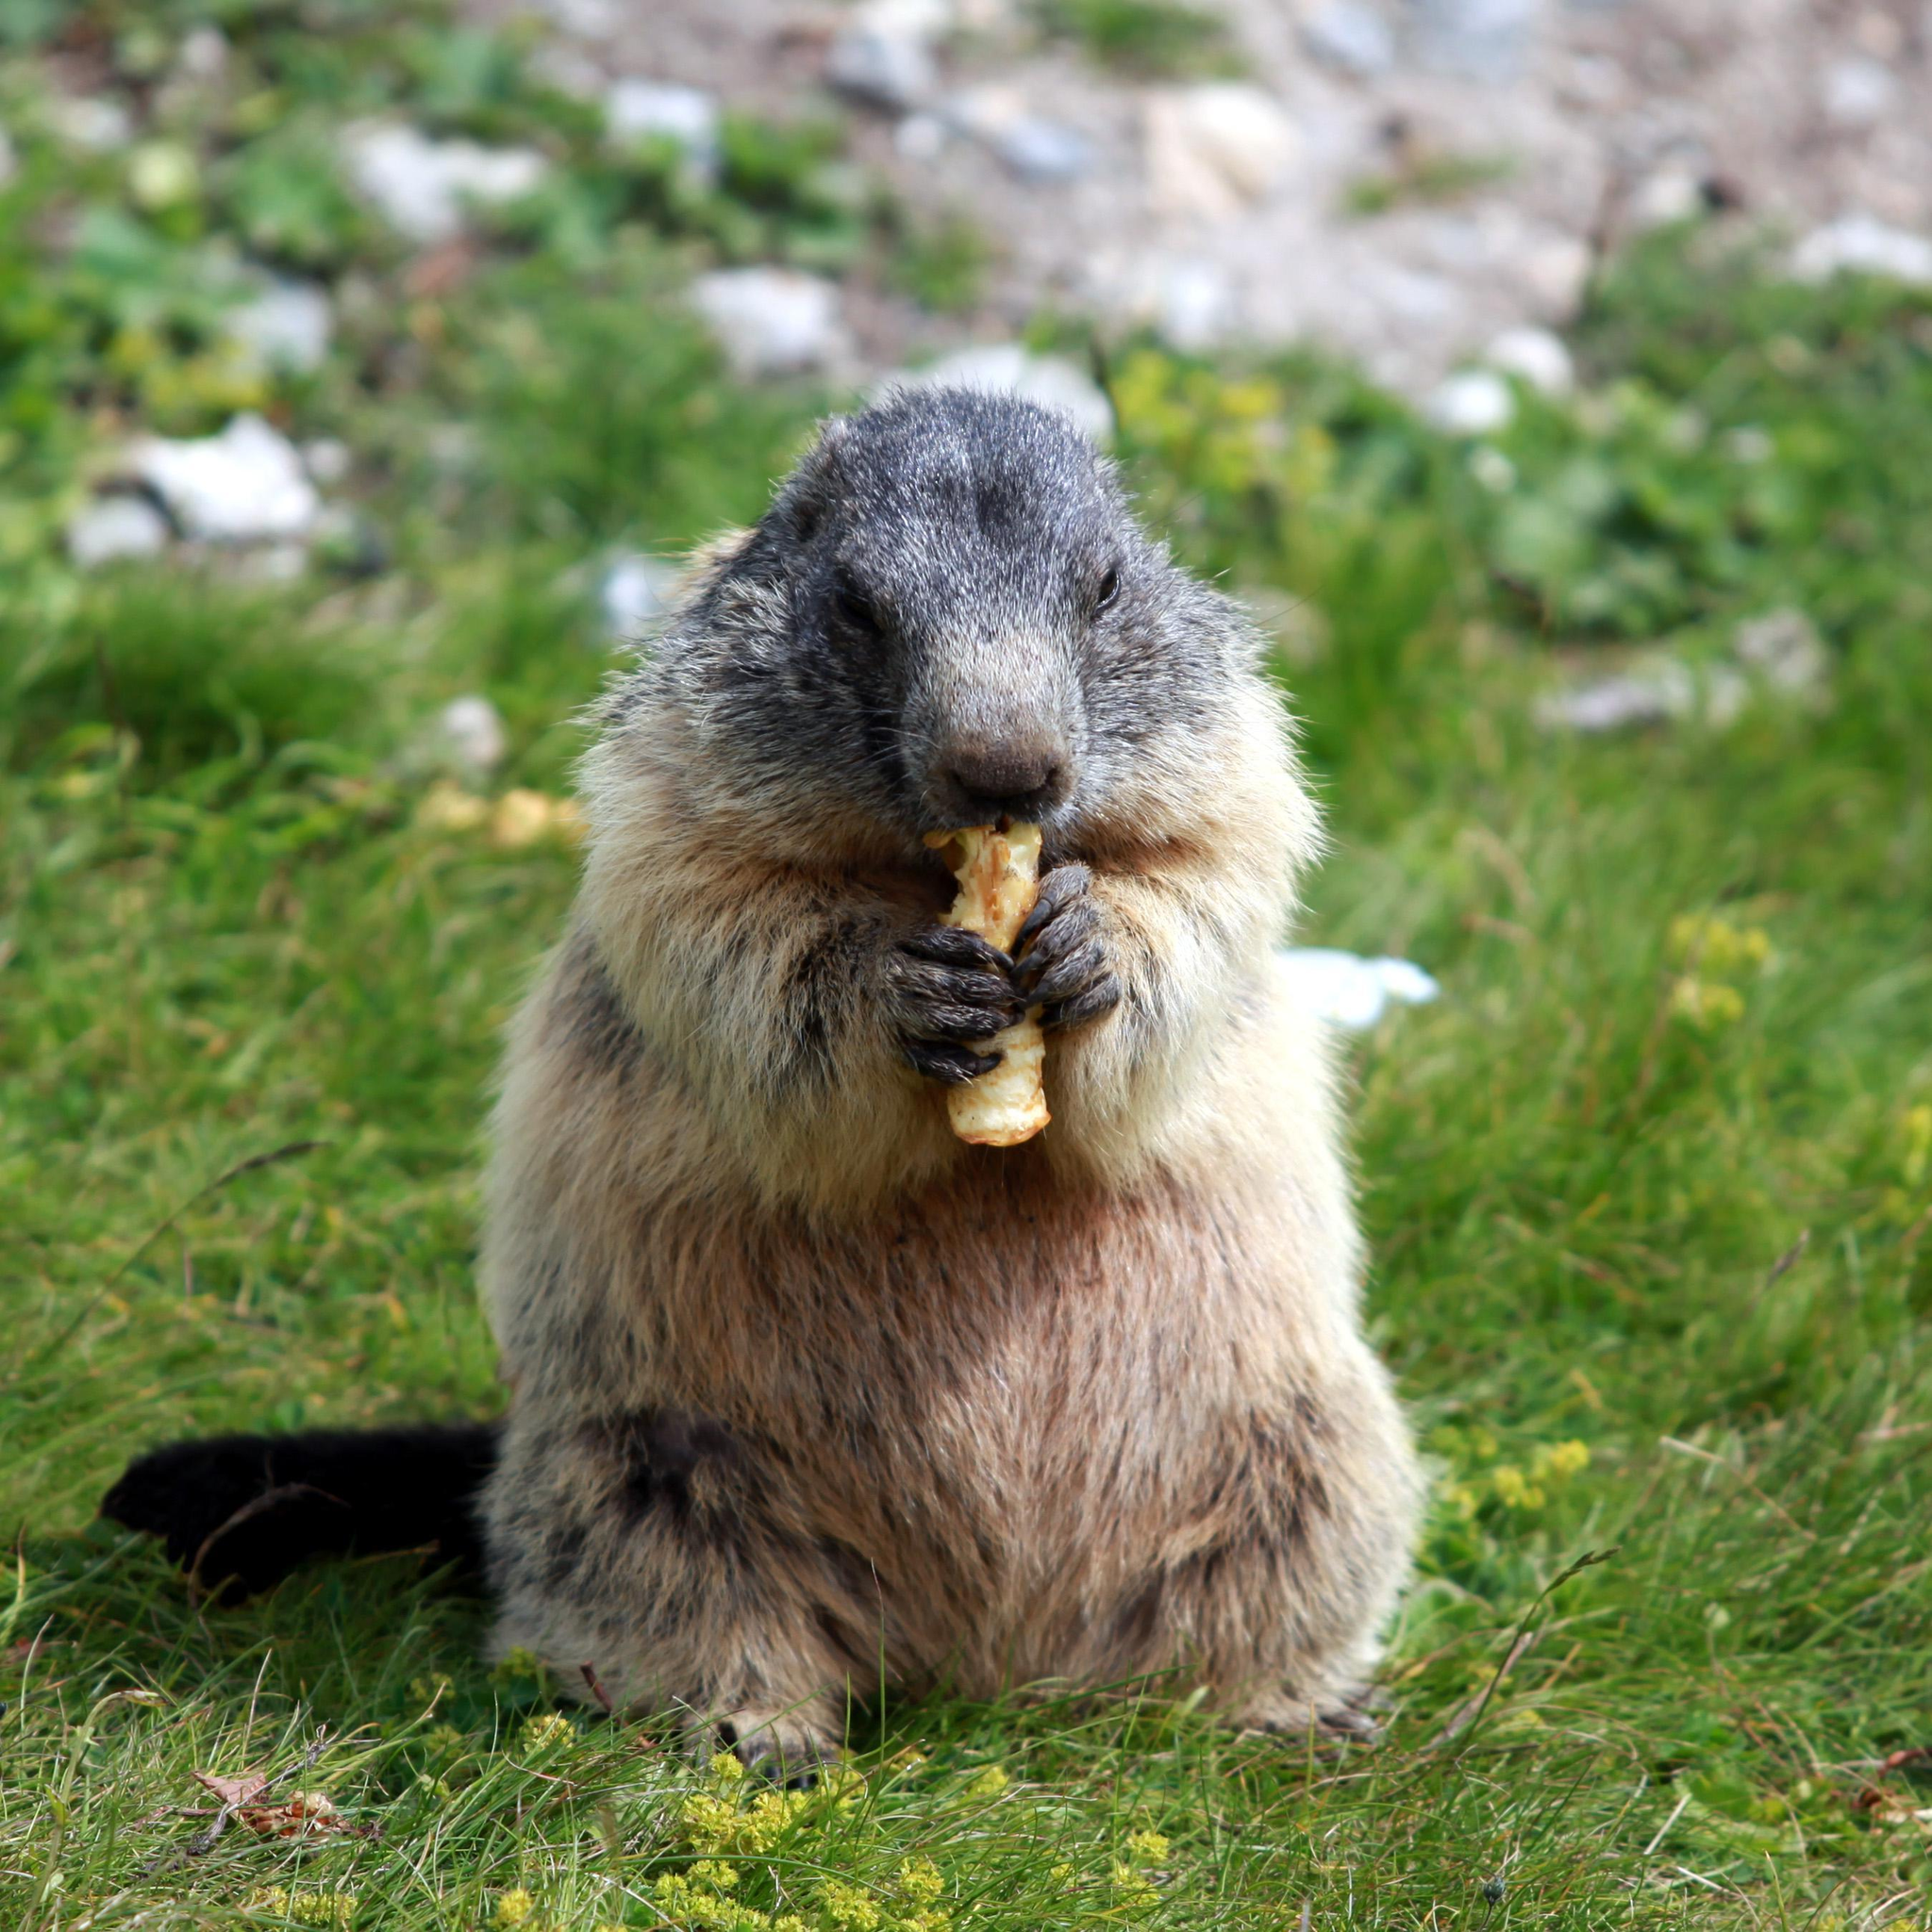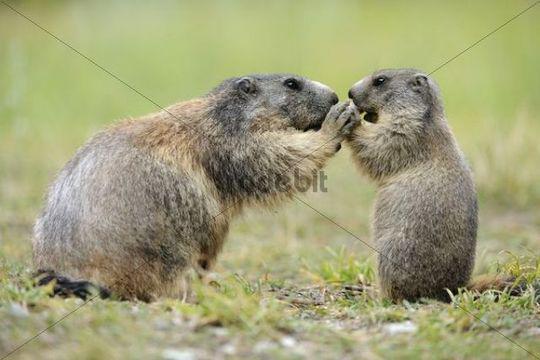The first image is the image on the left, the second image is the image on the right. Analyze the images presented: Is the assertion "The marmot on the left is eating something" valid? Answer yes or no. Yes. 